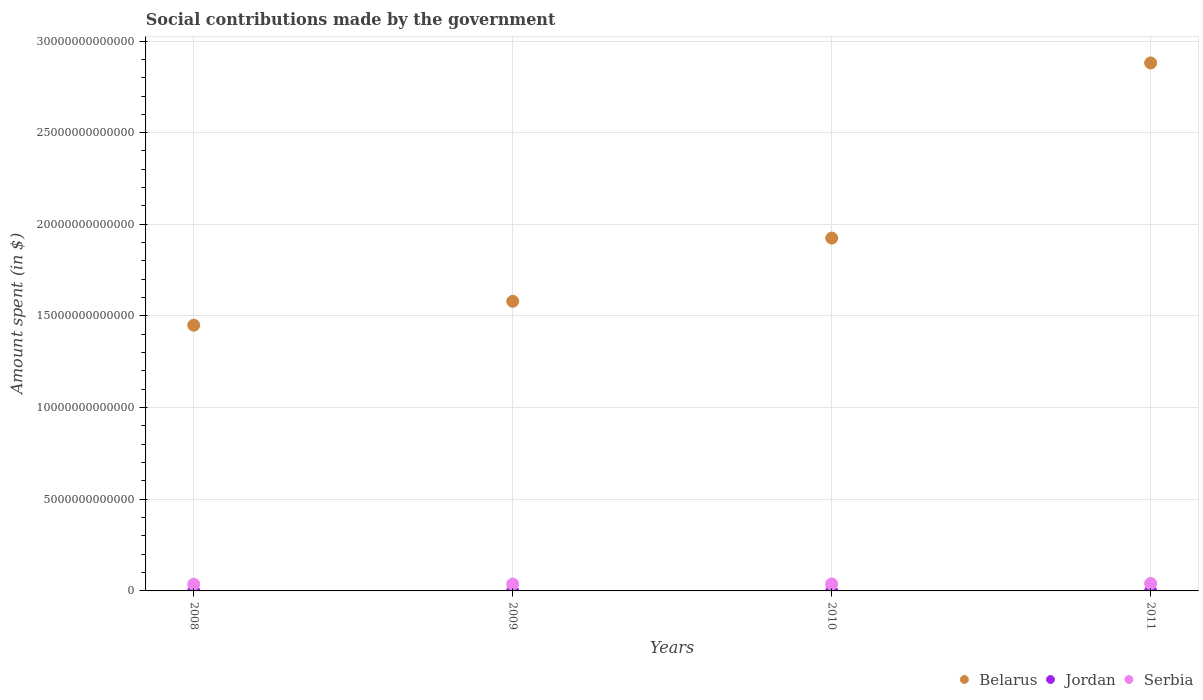How many different coloured dotlines are there?
Provide a succinct answer. 3. What is the amount spent on social contributions in Serbia in 2010?
Your answer should be compact. 3.79e+11. Across all years, what is the maximum amount spent on social contributions in Belarus?
Your response must be concise. 2.88e+13. Across all years, what is the minimum amount spent on social contributions in Belarus?
Make the answer very short. 1.45e+13. In which year was the amount spent on social contributions in Serbia maximum?
Your answer should be very brief. 2011. In which year was the amount spent on social contributions in Jordan minimum?
Provide a succinct answer. 2009. What is the total amount spent on social contributions in Jordan in the graph?
Give a very brief answer. 8.31e+07. What is the difference between the amount spent on social contributions in Belarus in 2008 and that in 2011?
Give a very brief answer. -1.43e+13. What is the difference between the amount spent on social contributions in Belarus in 2009 and the amount spent on social contributions in Serbia in 2010?
Your response must be concise. 1.54e+13. What is the average amount spent on social contributions in Belarus per year?
Offer a terse response. 1.96e+13. In the year 2009, what is the difference between the amount spent on social contributions in Belarus and amount spent on social contributions in Jordan?
Offer a terse response. 1.58e+13. In how many years, is the amount spent on social contributions in Belarus greater than 1000000000000 $?
Offer a terse response. 4. What is the ratio of the amount spent on social contributions in Belarus in 2008 to that in 2010?
Keep it short and to the point. 0.75. What is the difference between the highest and the lowest amount spent on social contributions in Jordan?
Your answer should be compact. 7.00e+05. In how many years, is the amount spent on social contributions in Serbia greater than the average amount spent on social contributions in Serbia taken over all years?
Give a very brief answer. 1. Is the sum of the amount spent on social contributions in Serbia in 2008 and 2009 greater than the maximum amount spent on social contributions in Jordan across all years?
Provide a succinct answer. Yes. How many dotlines are there?
Ensure brevity in your answer.  3. What is the difference between two consecutive major ticks on the Y-axis?
Your answer should be compact. 5.00e+12. Where does the legend appear in the graph?
Your answer should be compact. Bottom right. How many legend labels are there?
Give a very brief answer. 3. What is the title of the graph?
Provide a succinct answer. Social contributions made by the government. Does "Tunisia" appear as one of the legend labels in the graph?
Give a very brief answer. No. What is the label or title of the Y-axis?
Your answer should be compact. Amount spent (in $). What is the Amount spent (in $) of Belarus in 2008?
Provide a short and direct response. 1.45e+13. What is the Amount spent (in $) in Jordan in 2008?
Your answer should be very brief. 2.12e+07. What is the Amount spent (in $) in Serbia in 2008?
Your answer should be compact. 3.64e+11. What is the Amount spent (in $) of Belarus in 2009?
Offer a terse response. 1.58e+13. What is the Amount spent (in $) of Jordan in 2009?
Offer a very short reply. 2.05e+07. What is the Amount spent (in $) of Serbia in 2009?
Provide a succinct answer. 3.73e+11. What is the Amount spent (in $) of Belarus in 2010?
Provide a short and direct response. 1.92e+13. What is the Amount spent (in $) of Jordan in 2010?
Make the answer very short. 2.07e+07. What is the Amount spent (in $) of Serbia in 2010?
Give a very brief answer. 3.79e+11. What is the Amount spent (in $) in Belarus in 2011?
Provide a succinct answer. 2.88e+13. What is the Amount spent (in $) in Jordan in 2011?
Keep it short and to the point. 2.07e+07. What is the Amount spent (in $) of Serbia in 2011?
Make the answer very short. 4.07e+11. Across all years, what is the maximum Amount spent (in $) in Belarus?
Offer a terse response. 2.88e+13. Across all years, what is the maximum Amount spent (in $) of Jordan?
Provide a succinct answer. 2.12e+07. Across all years, what is the maximum Amount spent (in $) of Serbia?
Keep it short and to the point. 4.07e+11. Across all years, what is the minimum Amount spent (in $) in Belarus?
Ensure brevity in your answer.  1.45e+13. Across all years, what is the minimum Amount spent (in $) in Jordan?
Provide a succinct answer. 2.05e+07. Across all years, what is the minimum Amount spent (in $) of Serbia?
Your answer should be very brief. 3.64e+11. What is the total Amount spent (in $) of Belarus in the graph?
Provide a succinct answer. 7.83e+13. What is the total Amount spent (in $) of Jordan in the graph?
Your response must be concise. 8.31e+07. What is the total Amount spent (in $) in Serbia in the graph?
Your response must be concise. 1.52e+12. What is the difference between the Amount spent (in $) in Belarus in 2008 and that in 2009?
Provide a short and direct response. -1.30e+12. What is the difference between the Amount spent (in $) of Serbia in 2008 and that in 2009?
Your answer should be very brief. -8.99e+09. What is the difference between the Amount spent (in $) of Belarus in 2008 and that in 2010?
Provide a succinct answer. -4.75e+12. What is the difference between the Amount spent (in $) of Serbia in 2008 and that in 2010?
Your answer should be compact. -1.49e+1. What is the difference between the Amount spent (in $) of Belarus in 2008 and that in 2011?
Provide a succinct answer. -1.43e+13. What is the difference between the Amount spent (in $) in Jordan in 2008 and that in 2011?
Give a very brief answer. 5.00e+05. What is the difference between the Amount spent (in $) in Serbia in 2008 and that in 2011?
Give a very brief answer. -4.26e+1. What is the difference between the Amount spent (in $) in Belarus in 2009 and that in 2010?
Offer a very short reply. -3.45e+12. What is the difference between the Amount spent (in $) in Serbia in 2009 and that in 2010?
Keep it short and to the point. -5.94e+09. What is the difference between the Amount spent (in $) in Belarus in 2009 and that in 2011?
Your response must be concise. -1.30e+13. What is the difference between the Amount spent (in $) in Jordan in 2009 and that in 2011?
Offer a very short reply. -2.00e+05. What is the difference between the Amount spent (in $) of Serbia in 2009 and that in 2011?
Offer a terse response. -3.36e+1. What is the difference between the Amount spent (in $) in Belarus in 2010 and that in 2011?
Give a very brief answer. -9.55e+12. What is the difference between the Amount spent (in $) of Serbia in 2010 and that in 2011?
Your answer should be very brief. -2.77e+1. What is the difference between the Amount spent (in $) of Belarus in 2008 and the Amount spent (in $) of Jordan in 2009?
Make the answer very short. 1.45e+13. What is the difference between the Amount spent (in $) in Belarus in 2008 and the Amount spent (in $) in Serbia in 2009?
Ensure brevity in your answer.  1.41e+13. What is the difference between the Amount spent (in $) of Jordan in 2008 and the Amount spent (in $) of Serbia in 2009?
Your answer should be very brief. -3.73e+11. What is the difference between the Amount spent (in $) of Belarus in 2008 and the Amount spent (in $) of Jordan in 2010?
Provide a succinct answer. 1.45e+13. What is the difference between the Amount spent (in $) in Belarus in 2008 and the Amount spent (in $) in Serbia in 2010?
Provide a succinct answer. 1.41e+13. What is the difference between the Amount spent (in $) of Jordan in 2008 and the Amount spent (in $) of Serbia in 2010?
Make the answer very short. -3.79e+11. What is the difference between the Amount spent (in $) of Belarus in 2008 and the Amount spent (in $) of Jordan in 2011?
Make the answer very short. 1.45e+13. What is the difference between the Amount spent (in $) of Belarus in 2008 and the Amount spent (in $) of Serbia in 2011?
Provide a succinct answer. 1.41e+13. What is the difference between the Amount spent (in $) of Jordan in 2008 and the Amount spent (in $) of Serbia in 2011?
Make the answer very short. -4.07e+11. What is the difference between the Amount spent (in $) in Belarus in 2009 and the Amount spent (in $) in Jordan in 2010?
Keep it short and to the point. 1.58e+13. What is the difference between the Amount spent (in $) in Belarus in 2009 and the Amount spent (in $) in Serbia in 2010?
Ensure brevity in your answer.  1.54e+13. What is the difference between the Amount spent (in $) in Jordan in 2009 and the Amount spent (in $) in Serbia in 2010?
Keep it short and to the point. -3.79e+11. What is the difference between the Amount spent (in $) of Belarus in 2009 and the Amount spent (in $) of Jordan in 2011?
Offer a very short reply. 1.58e+13. What is the difference between the Amount spent (in $) in Belarus in 2009 and the Amount spent (in $) in Serbia in 2011?
Your answer should be compact. 1.54e+13. What is the difference between the Amount spent (in $) of Jordan in 2009 and the Amount spent (in $) of Serbia in 2011?
Give a very brief answer. -4.07e+11. What is the difference between the Amount spent (in $) in Belarus in 2010 and the Amount spent (in $) in Jordan in 2011?
Offer a very short reply. 1.92e+13. What is the difference between the Amount spent (in $) in Belarus in 2010 and the Amount spent (in $) in Serbia in 2011?
Provide a short and direct response. 1.88e+13. What is the difference between the Amount spent (in $) of Jordan in 2010 and the Amount spent (in $) of Serbia in 2011?
Your response must be concise. -4.07e+11. What is the average Amount spent (in $) of Belarus per year?
Ensure brevity in your answer.  1.96e+13. What is the average Amount spent (in $) of Jordan per year?
Offer a terse response. 2.08e+07. What is the average Amount spent (in $) of Serbia per year?
Provide a succinct answer. 3.81e+11. In the year 2008, what is the difference between the Amount spent (in $) of Belarus and Amount spent (in $) of Jordan?
Ensure brevity in your answer.  1.45e+13. In the year 2008, what is the difference between the Amount spent (in $) of Belarus and Amount spent (in $) of Serbia?
Your response must be concise. 1.41e+13. In the year 2008, what is the difference between the Amount spent (in $) in Jordan and Amount spent (in $) in Serbia?
Your response must be concise. -3.64e+11. In the year 2009, what is the difference between the Amount spent (in $) of Belarus and Amount spent (in $) of Jordan?
Make the answer very short. 1.58e+13. In the year 2009, what is the difference between the Amount spent (in $) in Belarus and Amount spent (in $) in Serbia?
Keep it short and to the point. 1.54e+13. In the year 2009, what is the difference between the Amount spent (in $) in Jordan and Amount spent (in $) in Serbia?
Your answer should be very brief. -3.73e+11. In the year 2010, what is the difference between the Amount spent (in $) in Belarus and Amount spent (in $) in Jordan?
Provide a short and direct response. 1.92e+13. In the year 2010, what is the difference between the Amount spent (in $) in Belarus and Amount spent (in $) in Serbia?
Keep it short and to the point. 1.89e+13. In the year 2010, what is the difference between the Amount spent (in $) in Jordan and Amount spent (in $) in Serbia?
Give a very brief answer. -3.79e+11. In the year 2011, what is the difference between the Amount spent (in $) in Belarus and Amount spent (in $) in Jordan?
Offer a terse response. 2.88e+13. In the year 2011, what is the difference between the Amount spent (in $) of Belarus and Amount spent (in $) of Serbia?
Your response must be concise. 2.84e+13. In the year 2011, what is the difference between the Amount spent (in $) in Jordan and Amount spent (in $) in Serbia?
Ensure brevity in your answer.  -4.07e+11. What is the ratio of the Amount spent (in $) of Belarus in 2008 to that in 2009?
Ensure brevity in your answer.  0.92. What is the ratio of the Amount spent (in $) of Jordan in 2008 to that in 2009?
Make the answer very short. 1.03. What is the ratio of the Amount spent (in $) in Serbia in 2008 to that in 2009?
Provide a short and direct response. 0.98. What is the ratio of the Amount spent (in $) in Belarus in 2008 to that in 2010?
Provide a short and direct response. 0.75. What is the ratio of the Amount spent (in $) in Jordan in 2008 to that in 2010?
Keep it short and to the point. 1.02. What is the ratio of the Amount spent (in $) of Serbia in 2008 to that in 2010?
Your response must be concise. 0.96. What is the ratio of the Amount spent (in $) in Belarus in 2008 to that in 2011?
Ensure brevity in your answer.  0.5. What is the ratio of the Amount spent (in $) in Jordan in 2008 to that in 2011?
Provide a succinct answer. 1.02. What is the ratio of the Amount spent (in $) in Serbia in 2008 to that in 2011?
Ensure brevity in your answer.  0.9. What is the ratio of the Amount spent (in $) of Belarus in 2009 to that in 2010?
Keep it short and to the point. 0.82. What is the ratio of the Amount spent (in $) of Jordan in 2009 to that in 2010?
Keep it short and to the point. 0.99. What is the ratio of the Amount spent (in $) of Serbia in 2009 to that in 2010?
Provide a short and direct response. 0.98. What is the ratio of the Amount spent (in $) in Belarus in 2009 to that in 2011?
Keep it short and to the point. 0.55. What is the ratio of the Amount spent (in $) of Jordan in 2009 to that in 2011?
Your response must be concise. 0.99. What is the ratio of the Amount spent (in $) in Serbia in 2009 to that in 2011?
Offer a very short reply. 0.92. What is the ratio of the Amount spent (in $) in Belarus in 2010 to that in 2011?
Keep it short and to the point. 0.67. What is the ratio of the Amount spent (in $) in Jordan in 2010 to that in 2011?
Your answer should be compact. 1. What is the ratio of the Amount spent (in $) of Serbia in 2010 to that in 2011?
Offer a very short reply. 0.93. What is the difference between the highest and the second highest Amount spent (in $) in Belarus?
Offer a terse response. 9.55e+12. What is the difference between the highest and the second highest Amount spent (in $) in Jordan?
Provide a succinct answer. 5.00e+05. What is the difference between the highest and the second highest Amount spent (in $) in Serbia?
Offer a terse response. 2.77e+1. What is the difference between the highest and the lowest Amount spent (in $) of Belarus?
Keep it short and to the point. 1.43e+13. What is the difference between the highest and the lowest Amount spent (in $) of Serbia?
Your answer should be very brief. 4.26e+1. 